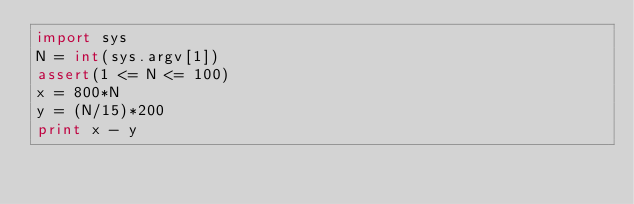<code> <loc_0><loc_0><loc_500><loc_500><_Python_>import sys
N = int(sys.argv[1])
assert(1 <= N <= 100)
x = 800*N
y = (N/15)*200
print x - y
</code> 